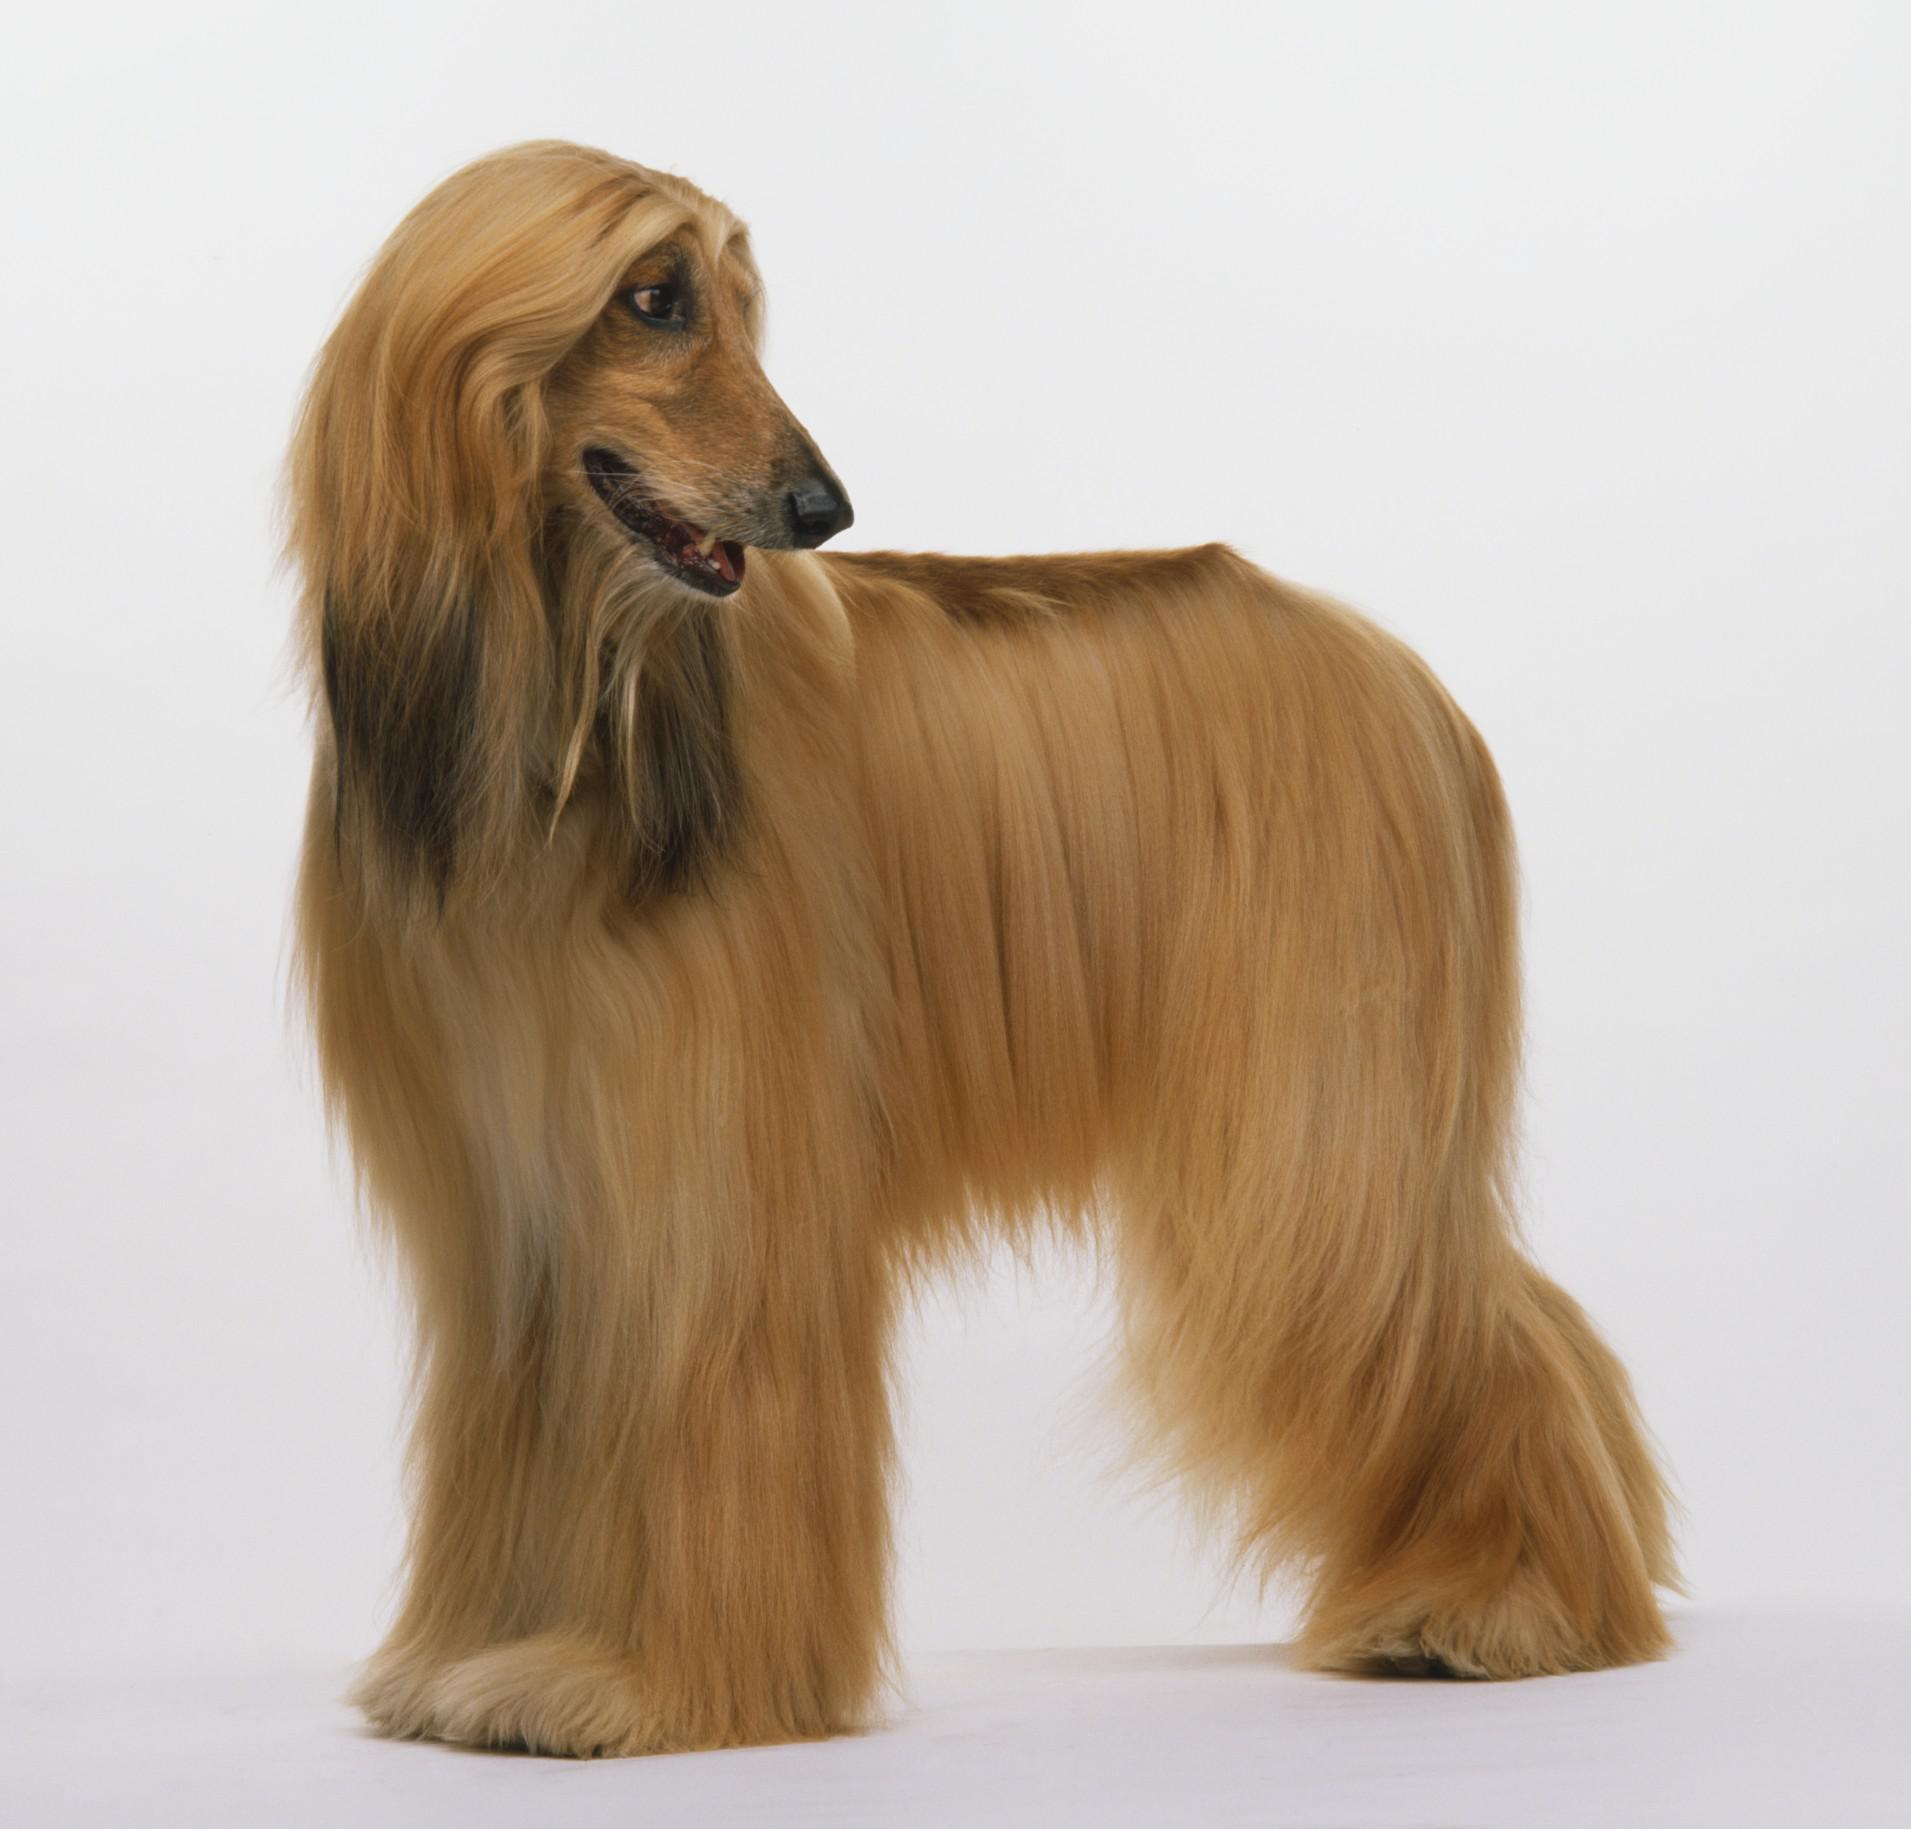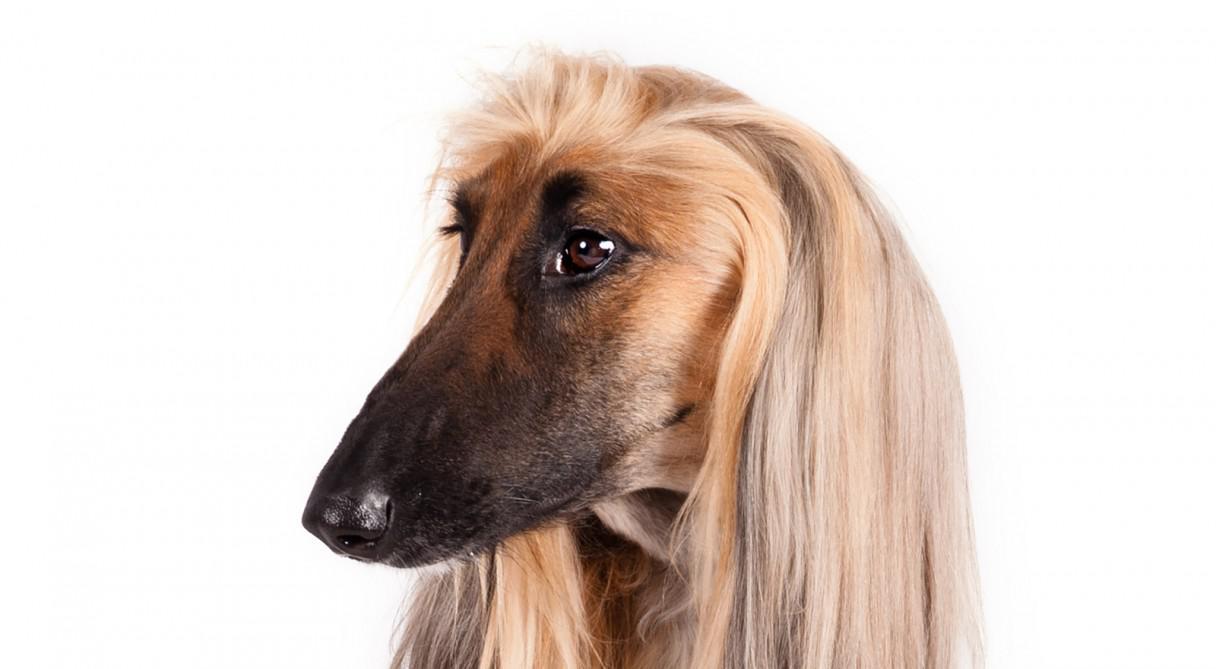The first image is the image on the left, the second image is the image on the right. For the images displayed, is the sentence "The dog in the image on the left is outside." factually correct? Answer yes or no. No. The first image is the image on the left, the second image is the image on the right. For the images displayed, is the sentence "Only the dogs head can be seen in the image on the right." factually correct? Answer yes or no. Yes. 